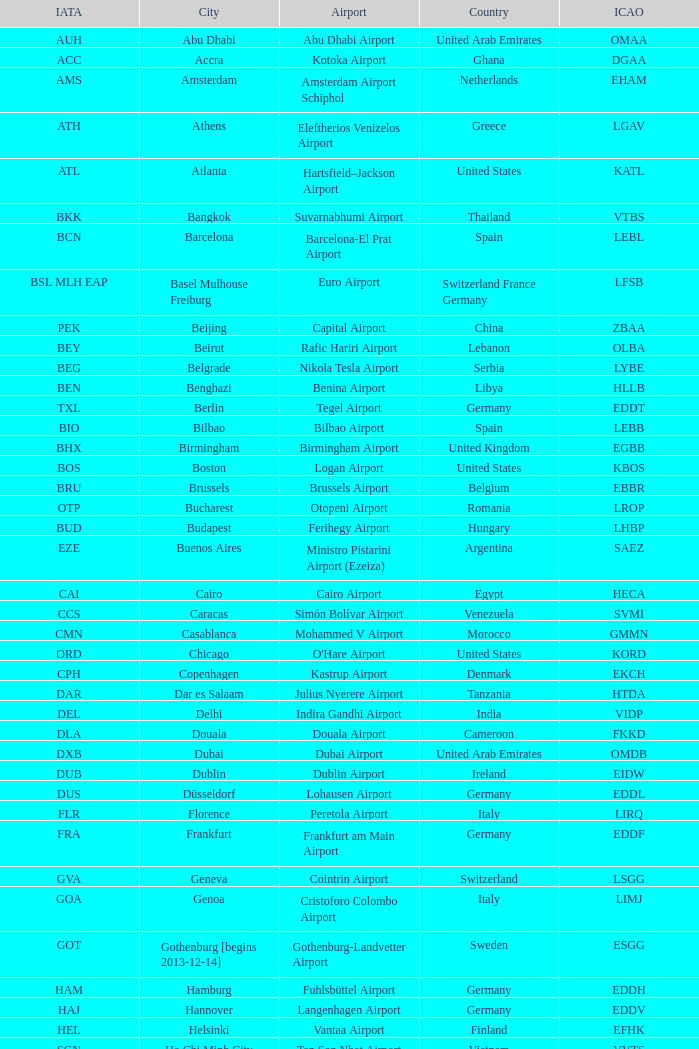What is the IATA of galeão airport? GIG. 